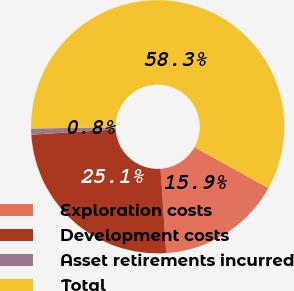Convert chart. <chart><loc_0><loc_0><loc_500><loc_500><pie_chart><fcel>Exploration costs<fcel>Development costs<fcel>Asset retirements incurred<fcel>Total<nl><fcel>15.88%<fcel>25.08%<fcel>0.78%<fcel>58.26%<nl></chart> 